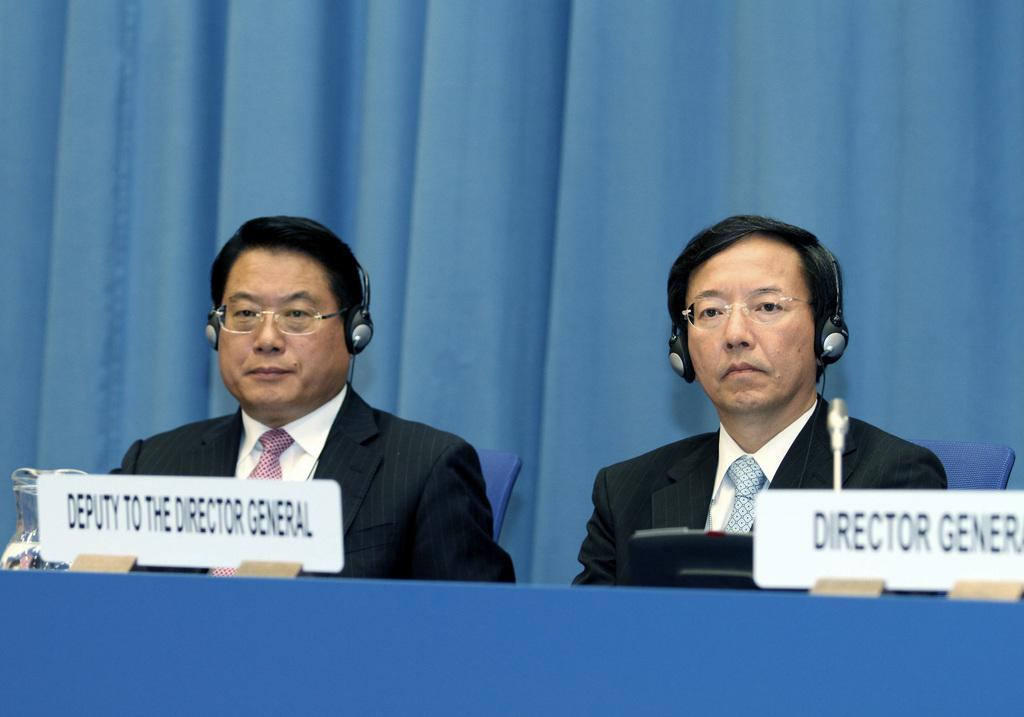Provide a one-sentence caption for the provided image. A director general and his deputy sit beind their respective signs at a table and are wearing headphones. 